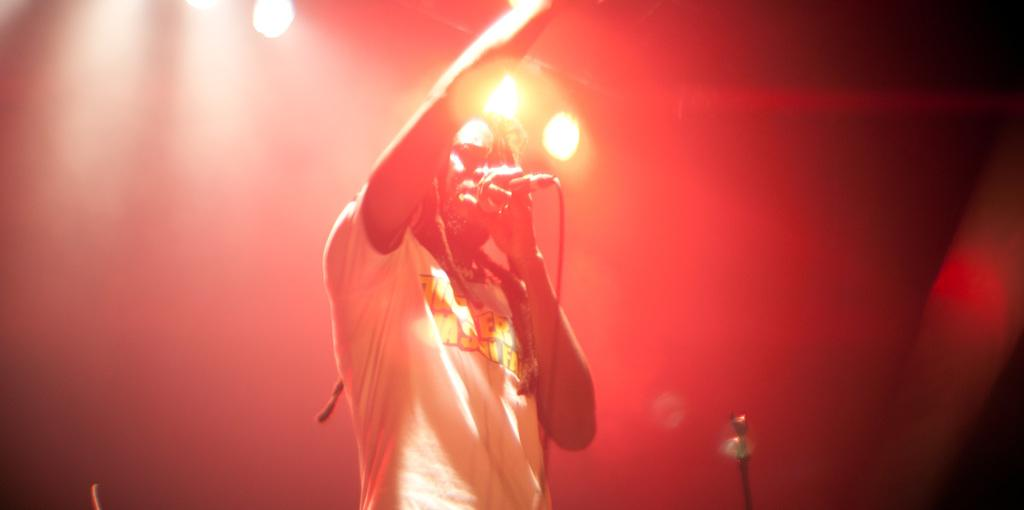Who is the person in the image? There is an African man in the image. What is the man wearing? The man is wearing a white t-shirt. What is the man doing in the image? The man is singing on a microphone. What color is the background in the image? The background in the image is red. What can be seen in the image that provides light? Spotlights are present in the image. What type of desk is the man using to sing in the image? There is no desk present in the image; the man is singing on a microphone. What role does the army play in the image? There is no mention of the army or any military elements in the image. 